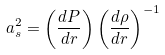Convert formula to latex. <formula><loc_0><loc_0><loc_500><loc_500>a _ { s } ^ { 2 } = \left ( \frac { d P } { d r } \right ) \left ( \frac { d \rho } { d r } \right ) ^ { - 1 }</formula> 